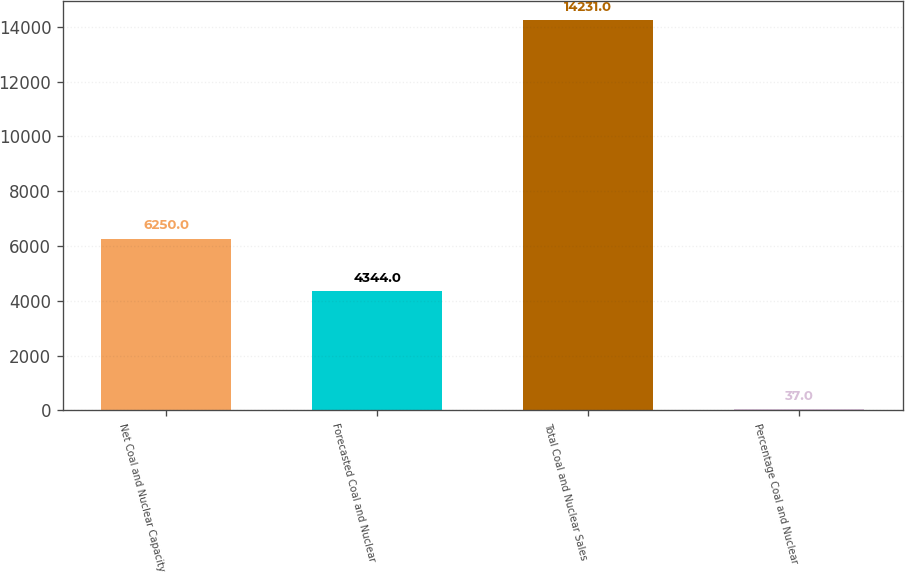Convert chart. <chart><loc_0><loc_0><loc_500><loc_500><bar_chart><fcel>Net Coal and Nuclear Capacity<fcel>Forecasted Coal and Nuclear<fcel>Total Coal and Nuclear Sales<fcel>Percentage Coal and Nuclear<nl><fcel>6250<fcel>4344<fcel>14231<fcel>37<nl></chart> 